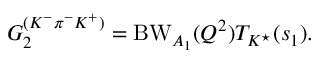<formula> <loc_0><loc_0><loc_500><loc_500>G _ { 2 } ^ { ( K ^ { - } \pi ^ { - } K ^ { + } ) } = B W _ { A _ { 1 } } ( Q ^ { 2 } ) T _ { K ^ { ^ { * } } } ( s _ { 1 } ) .</formula> 